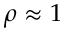<formula> <loc_0><loc_0><loc_500><loc_500>\rho \approx 1</formula> 